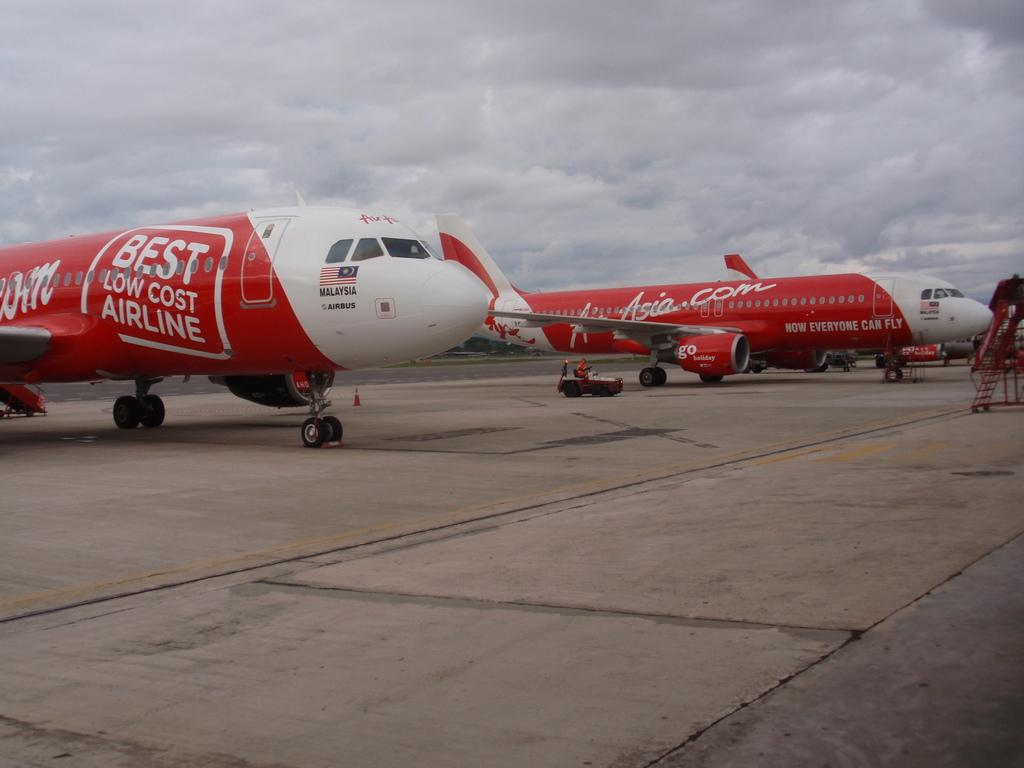What is the main subject of the image? The main subject of the image is aeroplanes. Where are the aeroplanes located in the image? The aeroplanes are in the center of the image. What type of view can be seen from the window of the achiever's office in the image? There is no mention of an achiever or an office in the image, and therefore no such view can be observed. 